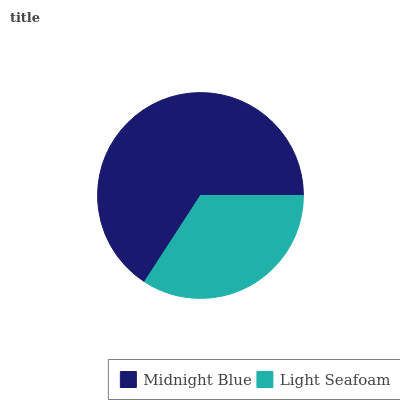Is Light Seafoam the minimum?
Answer yes or no. Yes. Is Midnight Blue the maximum?
Answer yes or no. Yes. Is Light Seafoam the maximum?
Answer yes or no. No. Is Midnight Blue greater than Light Seafoam?
Answer yes or no. Yes. Is Light Seafoam less than Midnight Blue?
Answer yes or no. Yes. Is Light Seafoam greater than Midnight Blue?
Answer yes or no. No. Is Midnight Blue less than Light Seafoam?
Answer yes or no. No. Is Midnight Blue the high median?
Answer yes or no. Yes. Is Light Seafoam the low median?
Answer yes or no. Yes. Is Light Seafoam the high median?
Answer yes or no. No. Is Midnight Blue the low median?
Answer yes or no. No. 